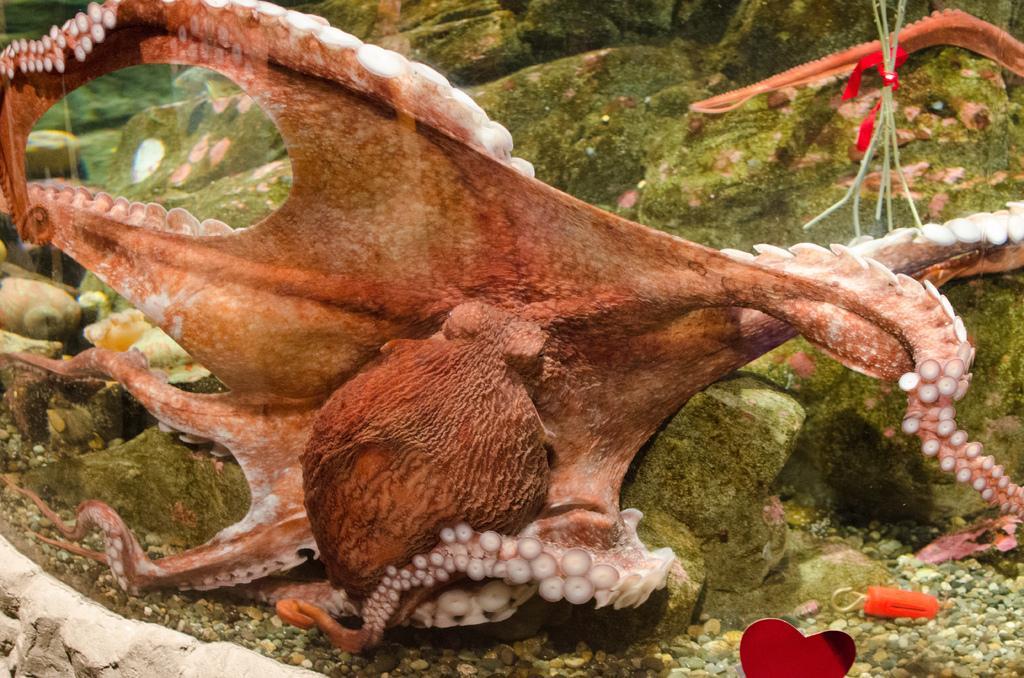How would you summarize this image in a sentence or two? In the picture we can see common octopus which is under water and we can see some stones. 